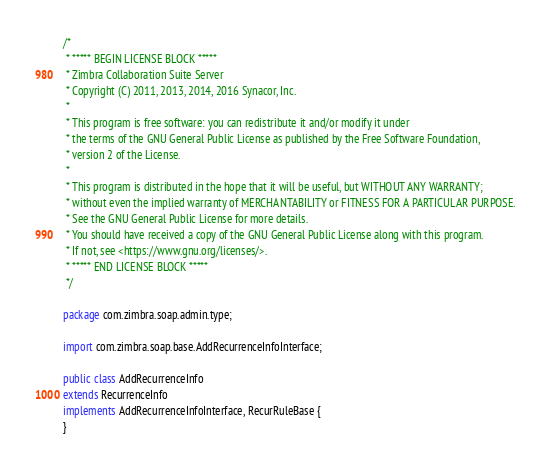<code> <loc_0><loc_0><loc_500><loc_500><_Java_>/*
 * ***** BEGIN LICENSE BLOCK *****
 * Zimbra Collaboration Suite Server
 * Copyright (C) 2011, 2013, 2014, 2016 Synacor, Inc.
 *
 * This program is free software: you can redistribute it and/or modify it under
 * the terms of the GNU General Public License as published by the Free Software Foundation,
 * version 2 of the License.
 *
 * This program is distributed in the hope that it will be useful, but WITHOUT ANY WARRANTY;
 * without even the implied warranty of MERCHANTABILITY or FITNESS FOR A PARTICULAR PURPOSE.
 * See the GNU General Public License for more details.
 * You should have received a copy of the GNU General Public License along with this program.
 * If not, see <https://www.gnu.org/licenses/>.
 * ***** END LICENSE BLOCK *****
 */

package com.zimbra.soap.admin.type;

import com.zimbra.soap.base.AddRecurrenceInfoInterface;

public class AddRecurrenceInfo
extends RecurrenceInfo
implements AddRecurrenceInfoInterface, RecurRuleBase {
}
</code> 